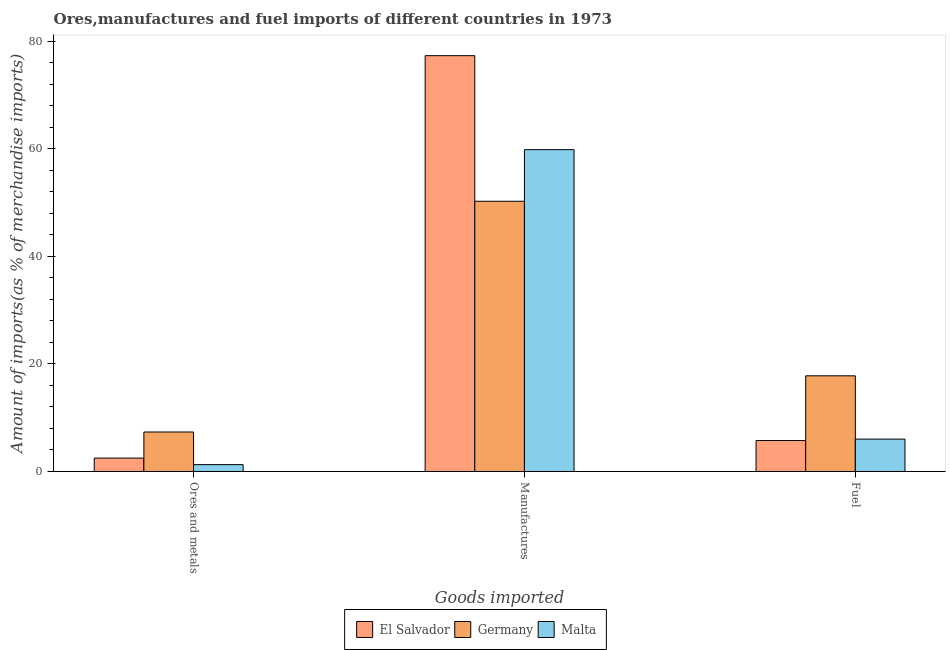How many different coloured bars are there?
Give a very brief answer. 3. How many groups of bars are there?
Your answer should be compact. 3. What is the label of the 2nd group of bars from the left?
Offer a very short reply. Manufactures. What is the percentage of fuel imports in Germany?
Your answer should be very brief. 17.8. Across all countries, what is the maximum percentage of manufactures imports?
Your answer should be compact. 77.36. Across all countries, what is the minimum percentage of ores and metals imports?
Give a very brief answer. 1.27. In which country was the percentage of manufactures imports maximum?
Provide a succinct answer. El Salvador. In which country was the percentage of fuel imports minimum?
Provide a short and direct response. El Salvador. What is the total percentage of fuel imports in the graph?
Provide a succinct answer. 29.58. What is the difference between the percentage of manufactures imports in El Salvador and that in Malta?
Provide a succinct answer. 17.49. What is the difference between the percentage of ores and metals imports in Germany and the percentage of manufactures imports in Malta?
Make the answer very short. -52.53. What is the average percentage of fuel imports per country?
Your answer should be very brief. 9.86. What is the difference between the percentage of fuel imports and percentage of manufactures imports in El Salvador?
Provide a succinct answer. -71.61. What is the ratio of the percentage of ores and metals imports in Germany to that in El Salvador?
Ensure brevity in your answer.  2.95. Is the percentage of manufactures imports in Germany less than that in Malta?
Provide a succinct answer. Yes. Is the difference between the percentage of ores and metals imports in El Salvador and Malta greater than the difference between the percentage of manufactures imports in El Salvador and Malta?
Your response must be concise. No. What is the difference between the highest and the second highest percentage of manufactures imports?
Make the answer very short. 17.49. What is the difference between the highest and the lowest percentage of manufactures imports?
Your response must be concise. 27.09. Is the sum of the percentage of ores and metals imports in Germany and El Salvador greater than the maximum percentage of fuel imports across all countries?
Provide a short and direct response. No. What does the 2nd bar from the left in Fuel represents?
Give a very brief answer. Germany. What does the 1st bar from the right in Fuel represents?
Ensure brevity in your answer.  Malta. Is it the case that in every country, the sum of the percentage of ores and metals imports and percentage of manufactures imports is greater than the percentage of fuel imports?
Provide a short and direct response. Yes. Are all the bars in the graph horizontal?
Make the answer very short. No. What is the difference between two consecutive major ticks on the Y-axis?
Your answer should be compact. 20. Does the graph contain grids?
Make the answer very short. No. Where does the legend appear in the graph?
Offer a very short reply. Bottom center. How are the legend labels stacked?
Offer a terse response. Horizontal. What is the title of the graph?
Provide a short and direct response. Ores,manufactures and fuel imports of different countries in 1973. What is the label or title of the X-axis?
Offer a terse response. Goods imported. What is the label or title of the Y-axis?
Offer a very short reply. Amount of imports(as % of merchandise imports). What is the Amount of imports(as % of merchandise imports) in El Salvador in Ores and metals?
Ensure brevity in your answer.  2.49. What is the Amount of imports(as % of merchandise imports) of Germany in Ores and metals?
Keep it short and to the point. 7.35. What is the Amount of imports(as % of merchandise imports) in Malta in Ores and metals?
Ensure brevity in your answer.  1.27. What is the Amount of imports(as % of merchandise imports) in El Salvador in Manufactures?
Your answer should be very brief. 77.36. What is the Amount of imports(as % of merchandise imports) of Germany in Manufactures?
Make the answer very short. 50.28. What is the Amount of imports(as % of merchandise imports) in Malta in Manufactures?
Ensure brevity in your answer.  59.87. What is the Amount of imports(as % of merchandise imports) of El Salvador in Fuel?
Your answer should be compact. 5.76. What is the Amount of imports(as % of merchandise imports) in Germany in Fuel?
Your answer should be compact. 17.8. What is the Amount of imports(as % of merchandise imports) in Malta in Fuel?
Offer a very short reply. 6.03. Across all Goods imported, what is the maximum Amount of imports(as % of merchandise imports) of El Salvador?
Your answer should be compact. 77.36. Across all Goods imported, what is the maximum Amount of imports(as % of merchandise imports) of Germany?
Your response must be concise. 50.28. Across all Goods imported, what is the maximum Amount of imports(as % of merchandise imports) of Malta?
Your answer should be compact. 59.87. Across all Goods imported, what is the minimum Amount of imports(as % of merchandise imports) in El Salvador?
Give a very brief answer. 2.49. Across all Goods imported, what is the minimum Amount of imports(as % of merchandise imports) in Germany?
Your answer should be compact. 7.35. Across all Goods imported, what is the minimum Amount of imports(as % of merchandise imports) of Malta?
Provide a short and direct response. 1.27. What is the total Amount of imports(as % of merchandise imports) in El Salvador in the graph?
Provide a short and direct response. 85.61. What is the total Amount of imports(as % of merchandise imports) in Germany in the graph?
Your answer should be very brief. 75.42. What is the total Amount of imports(as % of merchandise imports) in Malta in the graph?
Give a very brief answer. 67.18. What is the difference between the Amount of imports(as % of merchandise imports) in El Salvador in Ores and metals and that in Manufactures?
Keep it short and to the point. -74.87. What is the difference between the Amount of imports(as % of merchandise imports) in Germany in Ores and metals and that in Manufactures?
Your answer should be very brief. -42.93. What is the difference between the Amount of imports(as % of merchandise imports) in Malta in Ores and metals and that in Manufactures?
Provide a succinct answer. -58.6. What is the difference between the Amount of imports(as % of merchandise imports) of El Salvador in Ores and metals and that in Fuel?
Provide a short and direct response. -3.27. What is the difference between the Amount of imports(as % of merchandise imports) of Germany in Ores and metals and that in Fuel?
Offer a very short reply. -10.45. What is the difference between the Amount of imports(as % of merchandise imports) of Malta in Ores and metals and that in Fuel?
Your answer should be very brief. -4.75. What is the difference between the Amount of imports(as % of merchandise imports) in El Salvador in Manufactures and that in Fuel?
Offer a terse response. 71.61. What is the difference between the Amount of imports(as % of merchandise imports) in Germany in Manufactures and that in Fuel?
Offer a very short reply. 32.48. What is the difference between the Amount of imports(as % of merchandise imports) of Malta in Manufactures and that in Fuel?
Give a very brief answer. 53.84. What is the difference between the Amount of imports(as % of merchandise imports) of El Salvador in Ores and metals and the Amount of imports(as % of merchandise imports) of Germany in Manufactures?
Ensure brevity in your answer.  -47.79. What is the difference between the Amount of imports(as % of merchandise imports) of El Salvador in Ores and metals and the Amount of imports(as % of merchandise imports) of Malta in Manufactures?
Your response must be concise. -57.38. What is the difference between the Amount of imports(as % of merchandise imports) in Germany in Ores and metals and the Amount of imports(as % of merchandise imports) in Malta in Manufactures?
Give a very brief answer. -52.53. What is the difference between the Amount of imports(as % of merchandise imports) of El Salvador in Ores and metals and the Amount of imports(as % of merchandise imports) of Germany in Fuel?
Offer a terse response. -15.31. What is the difference between the Amount of imports(as % of merchandise imports) of El Salvador in Ores and metals and the Amount of imports(as % of merchandise imports) of Malta in Fuel?
Offer a terse response. -3.54. What is the difference between the Amount of imports(as % of merchandise imports) in Germany in Ores and metals and the Amount of imports(as % of merchandise imports) in Malta in Fuel?
Offer a very short reply. 1.32. What is the difference between the Amount of imports(as % of merchandise imports) of El Salvador in Manufactures and the Amount of imports(as % of merchandise imports) of Germany in Fuel?
Give a very brief answer. 59.56. What is the difference between the Amount of imports(as % of merchandise imports) in El Salvador in Manufactures and the Amount of imports(as % of merchandise imports) in Malta in Fuel?
Keep it short and to the point. 71.33. What is the difference between the Amount of imports(as % of merchandise imports) in Germany in Manufactures and the Amount of imports(as % of merchandise imports) in Malta in Fuel?
Provide a short and direct response. 44.25. What is the average Amount of imports(as % of merchandise imports) in El Salvador per Goods imported?
Offer a terse response. 28.54. What is the average Amount of imports(as % of merchandise imports) of Germany per Goods imported?
Ensure brevity in your answer.  25.14. What is the average Amount of imports(as % of merchandise imports) in Malta per Goods imported?
Offer a terse response. 22.39. What is the difference between the Amount of imports(as % of merchandise imports) in El Salvador and Amount of imports(as % of merchandise imports) in Germany in Ores and metals?
Your answer should be very brief. -4.86. What is the difference between the Amount of imports(as % of merchandise imports) of El Salvador and Amount of imports(as % of merchandise imports) of Malta in Ores and metals?
Offer a very short reply. 1.22. What is the difference between the Amount of imports(as % of merchandise imports) in Germany and Amount of imports(as % of merchandise imports) in Malta in Ores and metals?
Provide a short and direct response. 6.07. What is the difference between the Amount of imports(as % of merchandise imports) in El Salvador and Amount of imports(as % of merchandise imports) in Germany in Manufactures?
Make the answer very short. 27.09. What is the difference between the Amount of imports(as % of merchandise imports) of El Salvador and Amount of imports(as % of merchandise imports) of Malta in Manufactures?
Your answer should be compact. 17.49. What is the difference between the Amount of imports(as % of merchandise imports) in Germany and Amount of imports(as % of merchandise imports) in Malta in Manufactures?
Your response must be concise. -9.6. What is the difference between the Amount of imports(as % of merchandise imports) in El Salvador and Amount of imports(as % of merchandise imports) in Germany in Fuel?
Offer a terse response. -12.04. What is the difference between the Amount of imports(as % of merchandise imports) of El Salvador and Amount of imports(as % of merchandise imports) of Malta in Fuel?
Your answer should be compact. -0.27. What is the difference between the Amount of imports(as % of merchandise imports) in Germany and Amount of imports(as % of merchandise imports) in Malta in Fuel?
Your answer should be very brief. 11.77. What is the ratio of the Amount of imports(as % of merchandise imports) in El Salvador in Ores and metals to that in Manufactures?
Keep it short and to the point. 0.03. What is the ratio of the Amount of imports(as % of merchandise imports) of Germany in Ores and metals to that in Manufactures?
Offer a terse response. 0.15. What is the ratio of the Amount of imports(as % of merchandise imports) in Malta in Ores and metals to that in Manufactures?
Keep it short and to the point. 0.02. What is the ratio of the Amount of imports(as % of merchandise imports) of El Salvador in Ores and metals to that in Fuel?
Your response must be concise. 0.43. What is the ratio of the Amount of imports(as % of merchandise imports) of Germany in Ores and metals to that in Fuel?
Keep it short and to the point. 0.41. What is the ratio of the Amount of imports(as % of merchandise imports) of Malta in Ores and metals to that in Fuel?
Give a very brief answer. 0.21. What is the ratio of the Amount of imports(as % of merchandise imports) in El Salvador in Manufactures to that in Fuel?
Your response must be concise. 13.44. What is the ratio of the Amount of imports(as % of merchandise imports) of Germany in Manufactures to that in Fuel?
Your answer should be compact. 2.83. What is the ratio of the Amount of imports(as % of merchandise imports) of Malta in Manufactures to that in Fuel?
Your response must be concise. 9.93. What is the difference between the highest and the second highest Amount of imports(as % of merchandise imports) in El Salvador?
Keep it short and to the point. 71.61. What is the difference between the highest and the second highest Amount of imports(as % of merchandise imports) in Germany?
Your answer should be very brief. 32.48. What is the difference between the highest and the second highest Amount of imports(as % of merchandise imports) in Malta?
Offer a very short reply. 53.84. What is the difference between the highest and the lowest Amount of imports(as % of merchandise imports) of El Salvador?
Offer a very short reply. 74.87. What is the difference between the highest and the lowest Amount of imports(as % of merchandise imports) in Germany?
Ensure brevity in your answer.  42.93. What is the difference between the highest and the lowest Amount of imports(as % of merchandise imports) of Malta?
Ensure brevity in your answer.  58.6. 